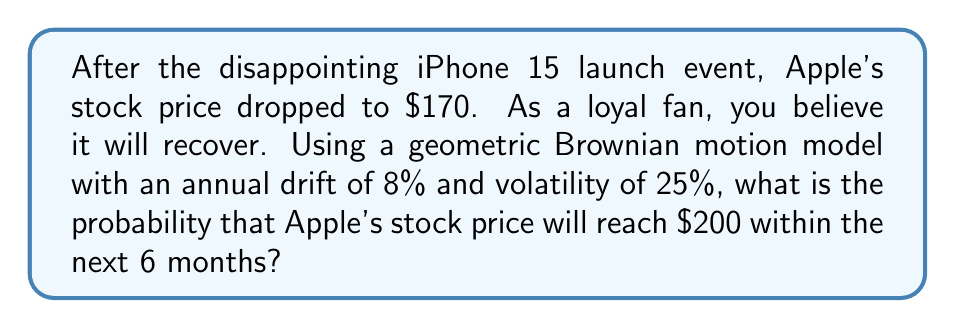Provide a solution to this math problem. Let's approach this step-by-step using the Black-Scholes framework:

1) First, we need to calculate the parameters for our model:
   - Current price (S₀) = $170
   - Target price (ST) = $200
   - Time (T) = 6 months = 0.5 years
   - Annual drift (μ) = 8% = 0.08
   - Annual volatility (σ) = 25% = 0.25

2) We'll use the formula for the probability of reaching a target price in geometric Brownian motion:

   $$P(S_T \geq ST) = N(d_1)$$

   Where $N(x)$ is the cumulative standard normal distribution function and

   $$d_1 = \frac{\ln(\frac{ST}{S_0}) - (μ - \frac{σ^2}{2})T}{σ\sqrt{T}}$$

3) Let's calculate $d_1$:

   $$d_1 = \frac{\ln(\frac{200}{170}) - (0.08 - \frac{0.25^2}{2}) * 0.5}{0.25 * \sqrt{0.5}}$$

4) Simplifying:
   
   $$d_1 = \frac{0.1625 - 0.0087}{0.1768} = 0.8698$$

5) Now we need to find $N(0.8698)$. Using a standard normal distribution table or calculator:

   $N(0.8698) ≈ 0.8078$

Therefore, the probability of Apple's stock reaching $200 within 6 months is approximately 0.8078 or 80.78%.
Answer: $0.8078$ or $80.78\%$ 